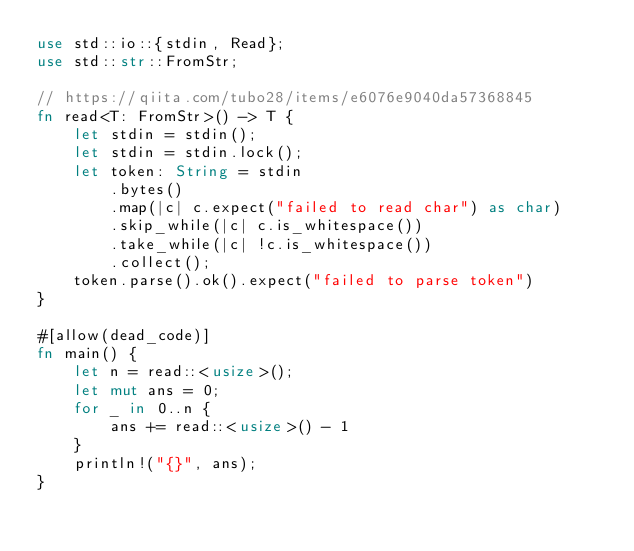<code> <loc_0><loc_0><loc_500><loc_500><_Rust_>use std::io::{stdin, Read};
use std::str::FromStr;

// https://qiita.com/tubo28/items/e6076e9040da57368845
fn read<T: FromStr>() -> T {
    let stdin = stdin();
    let stdin = stdin.lock();
    let token: String = stdin
        .bytes()
        .map(|c| c.expect("failed to read char") as char)
        .skip_while(|c| c.is_whitespace())
        .take_while(|c| !c.is_whitespace())
        .collect();
    token.parse().ok().expect("failed to parse token")
}

#[allow(dead_code)]
fn main() {
    let n = read::<usize>();
    let mut ans = 0;
    for _ in 0..n {
        ans += read::<usize>() - 1
    }
    println!("{}", ans);
}
</code> 